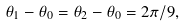Convert formula to latex. <formula><loc_0><loc_0><loc_500><loc_500>\theta _ { 1 } - \theta _ { 0 } = \theta _ { 2 } - \theta _ { 0 } = 2 \pi / 9 ,</formula> 